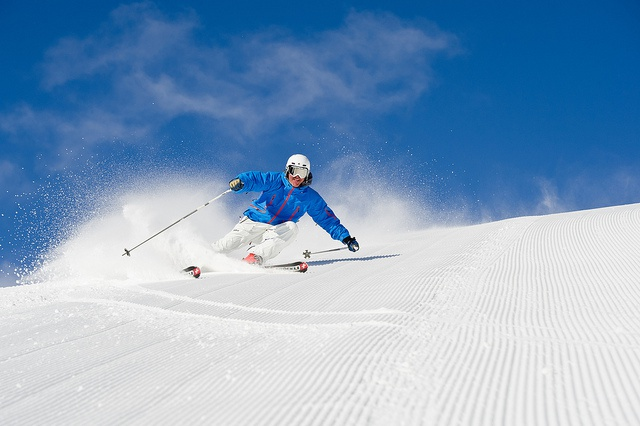Describe the objects in this image and their specific colors. I can see people in darkblue, lightgray, blue, and gray tones and skis in darkblue, lightgray, gray, darkgray, and black tones in this image. 